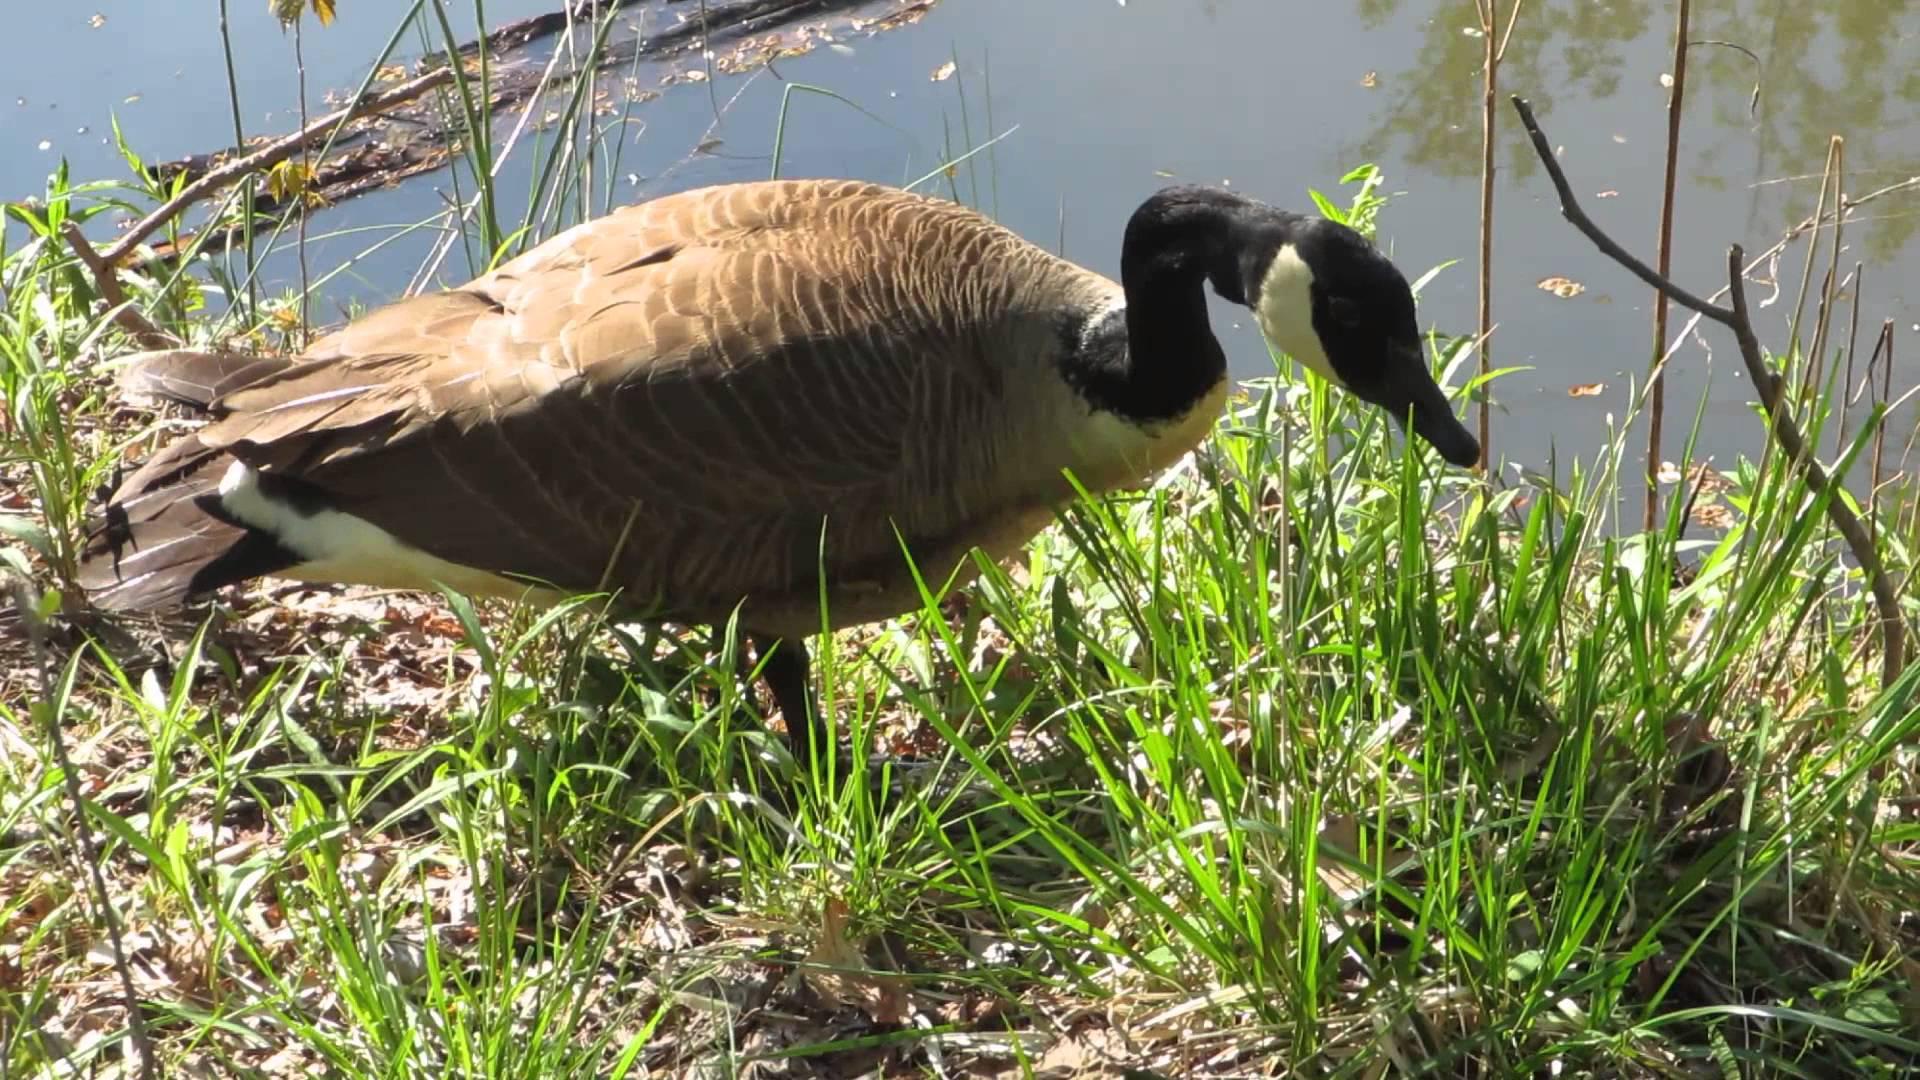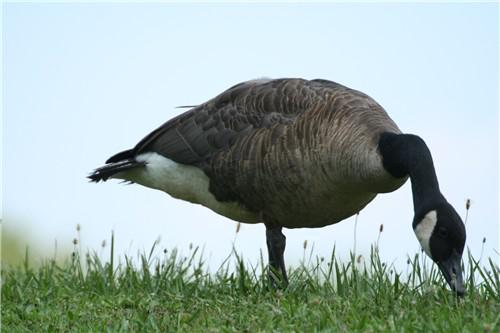The first image is the image on the left, the second image is the image on the right. Considering the images on both sides, is "Each image contains one black-necked goose, and each goose has its neck bent so its beak points downward." valid? Answer yes or no. Yes. The first image is the image on the left, the second image is the image on the right. Assess this claim about the two images: "The duck in the right image has its beak on the ground.". Correct or not? Answer yes or no. Yes. 